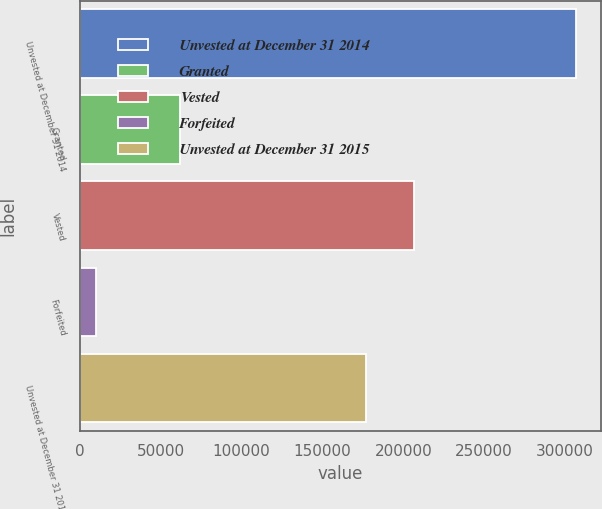<chart> <loc_0><loc_0><loc_500><loc_500><bar_chart><fcel>Unvested at December 31 2014<fcel>Granted<fcel>Vested<fcel>Forfeited<fcel>Unvested at December 31 2015<nl><fcel>306968<fcel>62128<fcel>206919<fcel>9915<fcel>177214<nl></chart> 